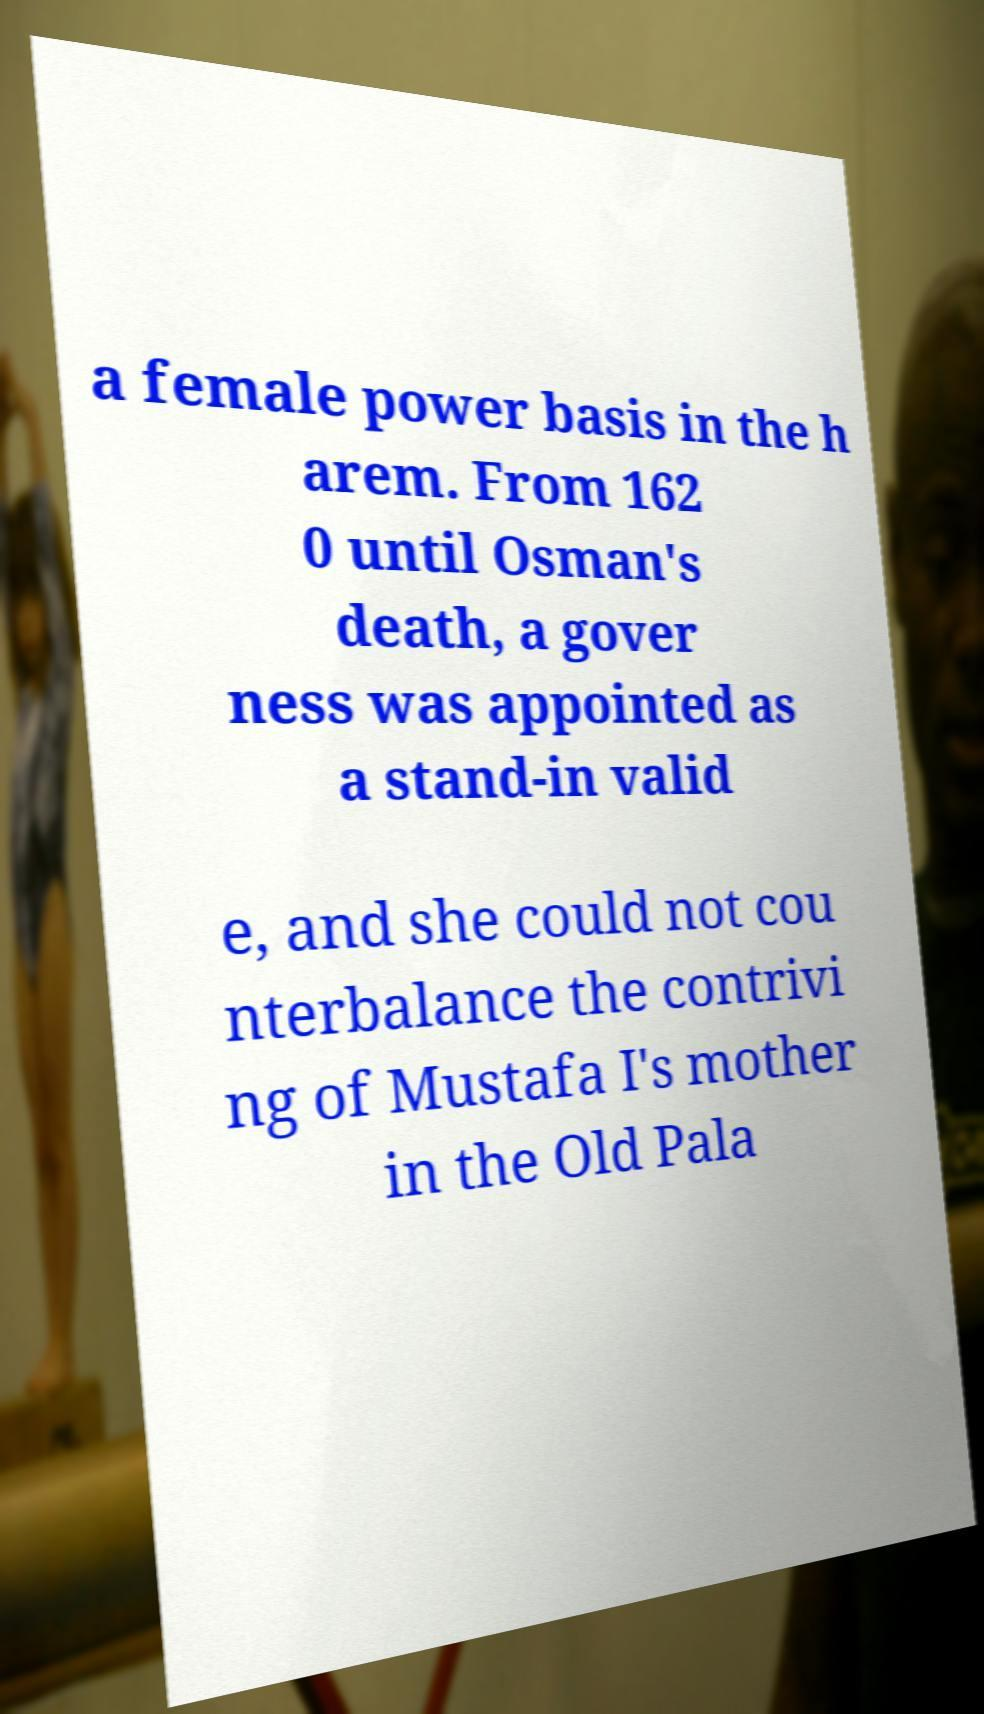Please identify and transcribe the text found in this image. a female power basis in the h arem. From 162 0 until Osman's death, a gover ness was appointed as a stand-in valid e, and she could not cou nterbalance the contrivi ng of Mustafa I's mother in the Old Pala 